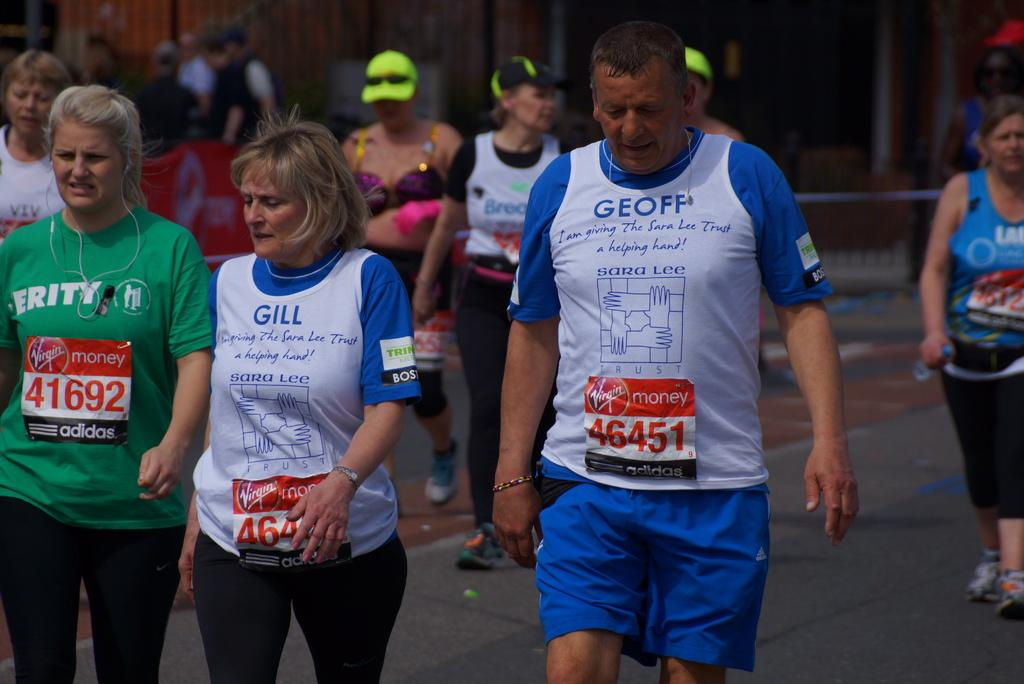<image>
Create a compact narrative representing the image presented. Participants in a marathon wearing Virgin Money number tags include #46451 and 41692. 